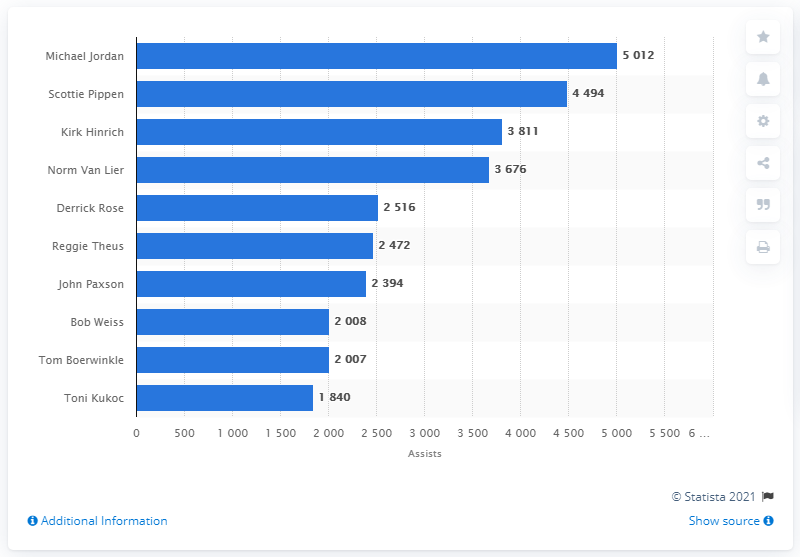Mention a couple of crucial points in this snapshot. The career assists leader of the Chicago Bulls is Michael Jordan. 